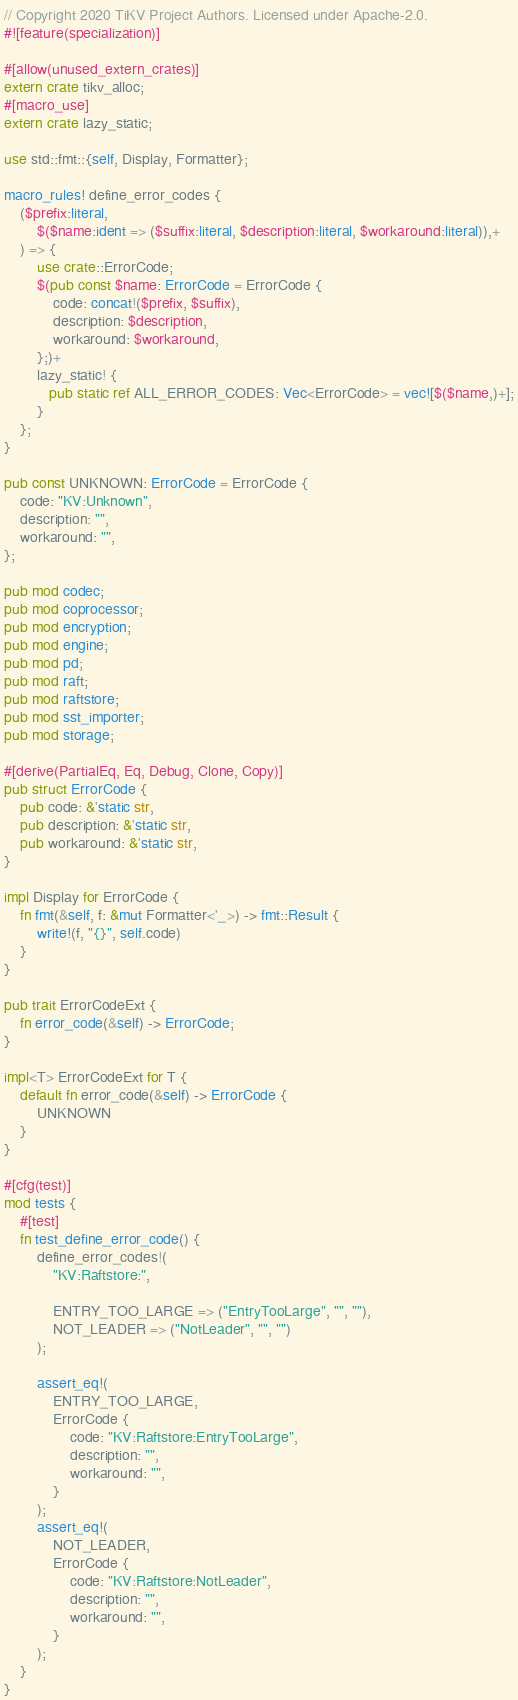<code> <loc_0><loc_0><loc_500><loc_500><_Rust_>// Copyright 2020 TiKV Project Authors. Licensed under Apache-2.0.
#![feature(specialization)]

#[allow(unused_extern_crates)]
extern crate tikv_alloc;
#[macro_use]
extern crate lazy_static;

use std::fmt::{self, Display, Formatter};

macro_rules! define_error_codes {
    ($prefix:literal,
        $($name:ident => ($suffix:literal, $description:literal, $workaround:literal)),+
    ) => {
        use crate::ErrorCode;
        $(pub const $name: ErrorCode = ErrorCode {
            code: concat!($prefix, $suffix),
            description: $description,
            workaround: $workaround,
        };)+
        lazy_static! {
           pub static ref ALL_ERROR_CODES: Vec<ErrorCode> = vec![$($name,)+];
        }
    };
}

pub const UNKNOWN: ErrorCode = ErrorCode {
    code: "KV:Unknown",
    description: "",
    workaround: "",
};

pub mod codec;
pub mod coprocessor;
pub mod encryption;
pub mod engine;
pub mod pd;
pub mod raft;
pub mod raftstore;
pub mod sst_importer;
pub mod storage;

#[derive(PartialEq, Eq, Debug, Clone, Copy)]
pub struct ErrorCode {
    pub code: &'static str,
    pub description: &'static str,
    pub workaround: &'static str,
}

impl Display for ErrorCode {
    fn fmt(&self, f: &mut Formatter<'_>) -> fmt::Result {
        write!(f, "{}", self.code)
    }
}

pub trait ErrorCodeExt {
    fn error_code(&self) -> ErrorCode;
}

impl<T> ErrorCodeExt for T {
    default fn error_code(&self) -> ErrorCode {
        UNKNOWN
    }
}

#[cfg(test)]
mod tests {
    #[test]
    fn test_define_error_code() {
        define_error_codes!(
            "KV:Raftstore:",

            ENTRY_TOO_LARGE => ("EntryTooLarge", "", ""),
            NOT_LEADER => ("NotLeader", "", "")
        );

        assert_eq!(
            ENTRY_TOO_LARGE,
            ErrorCode {
                code: "KV:Raftstore:EntryTooLarge",
                description: "",
                workaround: "",
            }
        );
        assert_eq!(
            NOT_LEADER,
            ErrorCode {
                code: "KV:Raftstore:NotLeader",
                description: "",
                workaround: "",
            }
        );
    }
}
</code> 